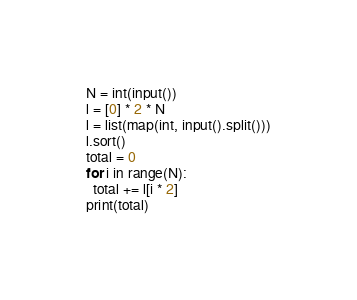<code> <loc_0><loc_0><loc_500><loc_500><_Python_>N = int(input())
l = [0] * 2 * N
l = list(map(int, input().split()))
l.sort()
total = 0
for i in range(N):
  total += l[i * 2]
print(total)</code> 